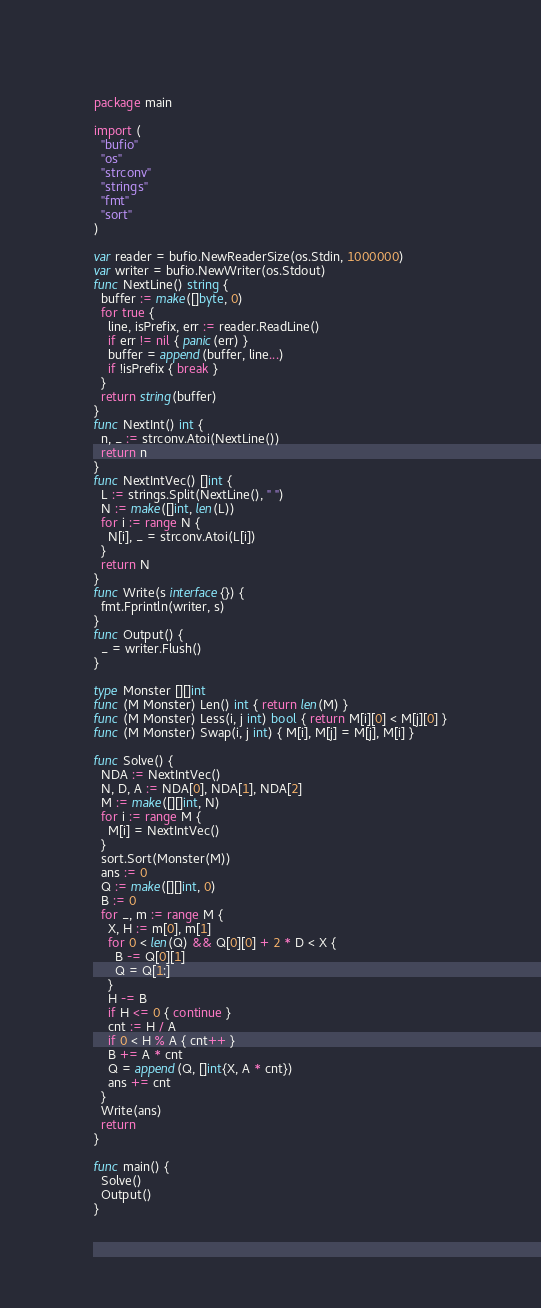<code> <loc_0><loc_0><loc_500><loc_500><_Go_>package main

import (
  "bufio"
  "os"
  "strconv"
  "strings"
  "fmt"
  "sort"
)

var reader = bufio.NewReaderSize(os.Stdin, 1000000)
var writer = bufio.NewWriter(os.Stdout)
func NextLine() string {
  buffer := make([]byte, 0)
  for true {
    line, isPrefix, err := reader.ReadLine()
    if err != nil { panic(err) }
    buffer = append(buffer, line...)
    if !isPrefix { break }
  }
  return string(buffer)
}
func NextInt() int {
  n, _ := strconv.Atoi(NextLine())
  return n
}
func NextIntVec() []int {
  L := strings.Split(NextLine(), " ")
  N := make([]int, len(L))
  for i := range N {
    N[i], _ = strconv.Atoi(L[i])
  }
  return N
}
func Write(s interface{}) {
  fmt.Fprintln(writer, s)
}
func Output() {
  _ = writer.Flush()
}

type Monster [][]int
func (M Monster) Len() int { return len(M) }
func (M Monster) Less(i, j int) bool { return M[i][0] < M[j][0] }
func (M Monster) Swap(i, j int) { M[i], M[j] = M[j], M[i] }

func Solve() {
  NDA := NextIntVec()
  N, D, A := NDA[0], NDA[1], NDA[2]
  M := make([][]int, N)
  for i := range M {
    M[i] = NextIntVec()
  }
  sort.Sort(Monster(M))
  ans := 0
  Q := make([][]int, 0)
  B := 0
  for _, m := range M {
    X, H := m[0], m[1]
    for 0 < len(Q) && Q[0][0] + 2 * D < X {
      B -= Q[0][1]
      Q = Q[1:]
    }
    H -= B
    if H <= 0 { continue }
    cnt := H / A
    if 0 < H % A { cnt++ }
    B += A * cnt
    Q = append(Q, []int{X, A * cnt})
    ans += cnt
  }
  Write(ans)
  return
}

func main() {
  Solve()
  Output()
}</code> 